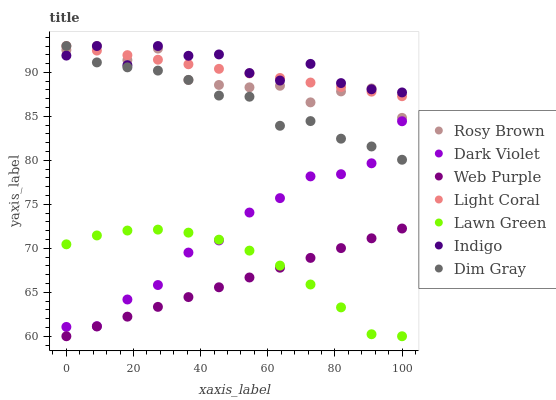Does Web Purple have the minimum area under the curve?
Answer yes or no. Yes. Does Indigo have the maximum area under the curve?
Answer yes or no. Yes. Does Dim Gray have the minimum area under the curve?
Answer yes or no. No. Does Dim Gray have the maximum area under the curve?
Answer yes or no. No. Is Web Purple the smoothest?
Answer yes or no. Yes. Is Indigo the roughest?
Answer yes or no. Yes. Is Dim Gray the smoothest?
Answer yes or no. No. Is Dim Gray the roughest?
Answer yes or no. No. Does Lawn Green have the lowest value?
Answer yes or no. Yes. Does Dim Gray have the lowest value?
Answer yes or no. No. Does Light Coral have the highest value?
Answer yes or no. Yes. Does Dark Violet have the highest value?
Answer yes or no. No. Is Web Purple less than Dark Violet?
Answer yes or no. Yes. Is Rosy Brown greater than Web Purple?
Answer yes or no. Yes. Does Lawn Green intersect Dark Violet?
Answer yes or no. Yes. Is Lawn Green less than Dark Violet?
Answer yes or no. No. Is Lawn Green greater than Dark Violet?
Answer yes or no. No. Does Web Purple intersect Dark Violet?
Answer yes or no. No. 